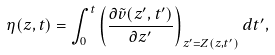<formula> <loc_0><loc_0><loc_500><loc_500>\eta ( z , t ) = \int _ { 0 } ^ { t } \left ( \frac { \partial \tilde { v } ( z ^ { \prime } , t ^ { \prime } ) } { \partial z ^ { \prime } } \right ) _ { z ^ { \prime } = Z ( z , t ^ { \prime } ) } d t ^ { \prime } ,</formula> 